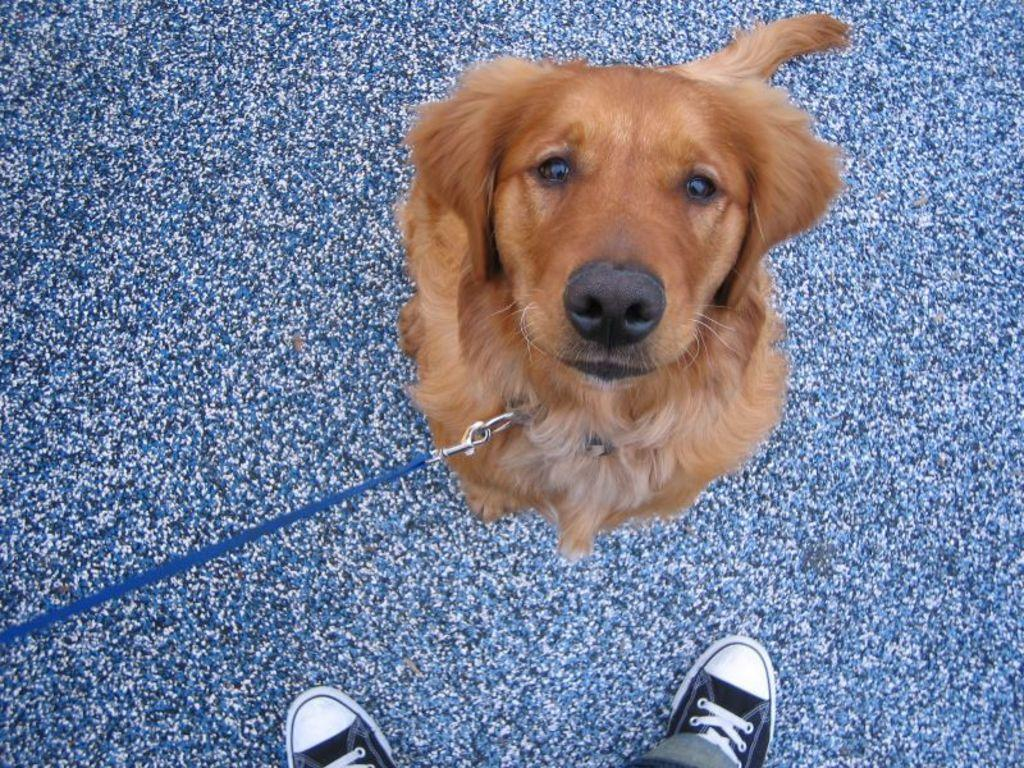What type of animal is present in the image? There is a dog in the image. What else can be seen in the image besides the dog? There are shoes of a person in the image. What is located at the bottom of the image? There is a mat at the bottom of the image. What type of calculator can be seen in the image? There is no calculator present in the image. 